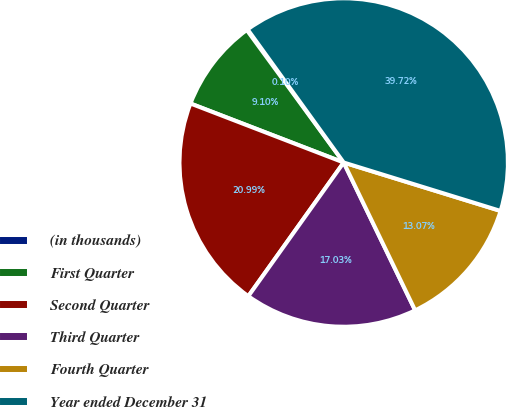Convert chart to OTSL. <chart><loc_0><loc_0><loc_500><loc_500><pie_chart><fcel>(in thousands)<fcel>First Quarter<fcel>Second Quarter<fcel>Third Quarter<fcel>Fourth Quarter<fcel>Year ended December 31<nl><fcel>0.1%<fcel>9.1%<fcel>20.99%<fcel>17.03%<fcel>13.07%<fcel>39.72%<nl></chart> 